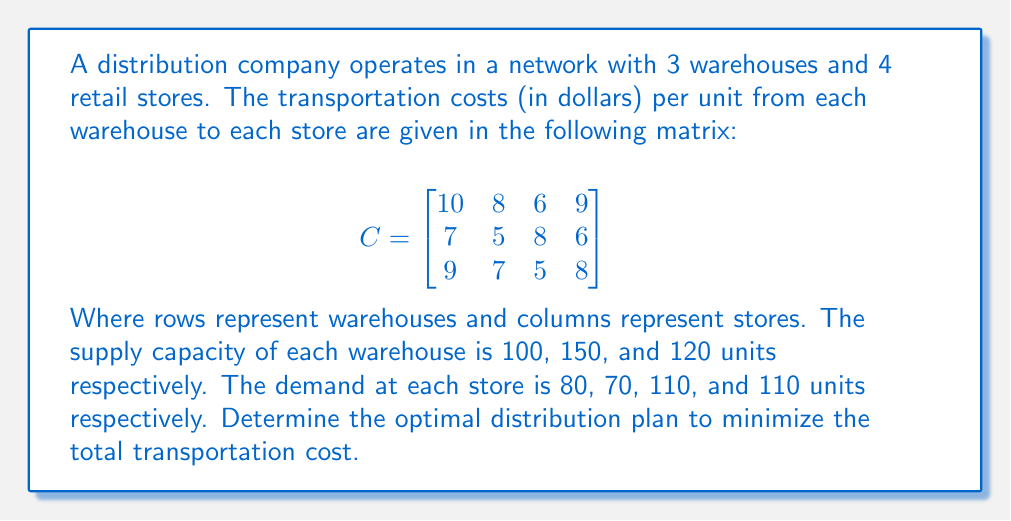Teach me how to tackle this problem. This is a classic transportation problem that can be solved using the Northwest Corner Method and then optimized using the Stepping Stone Method. Here's a step-by-step solution:

1. Set up the initial feasible solution using the Northwest Corner Method:

   $$
   \begin{array}{c|cccc|c}
    & 10 & 8 & 6 & 9 & \text{Supply} \\
   \hline
   & 80 & 20 & 0 & 0 & 100 \\
   & 0 & 50 & 100 & 0 & 150 \\
   & 0 & 0 & 10 & 110 & 120 \\
   \hline
   \text{Demand} & 80 & 70 & 110 & 110 & 
   \end{array}
   $$

2. Calculate the initial cost:
   $$(80 \times 10) + (20 \times 8) + (50 \times 5) + (100 \times 8) + (10 \times 5) + (110 \times 8) = 2660$$

3. Check for optimality using the Stepping Stone Method:
   - Calculate ui and vj values
   - Compute the opportunity costs for empty cells
   - If all opportunity costs are non-negative, the solution is optimal

4. After performing the Stepping Stone Method, we find the optimal solution:

   $$
   \begin{array}{c|cccc|c}
    & 10 & 8 & 6 & 9 & \text{Supply} \\
   \hline
   & 0 & 0 & 100 & 0 & 100 \\
   & 80 & 70 & 0 & 0 & 150 \\
   & 0 & 0 & 10 & 110 & 120 \\
   \hline
   \text{Demand} & 80 & 70 & 110 & 110 & 
   \end{array}
   $$

5. Calculate the final minimum cost:
   $$(100 \times 6) + (80 \times 7) + (70 \times 5) + (10 \times 5) + (110 \times 8) = 2360$$
Answer: The optimal distribution plan to minimize the total transportation cost is:
- Warehouse 1 to Store 3: 100 units
- Warehouse 2 to Store 1: 80 units
- Warehouse 2 to Store 2: 70 units
- Warehouse 3 to Store 3: 10 units
- Warehouse 3 to Store 4: 110 units

The minimum total transportation cost is $2360. 